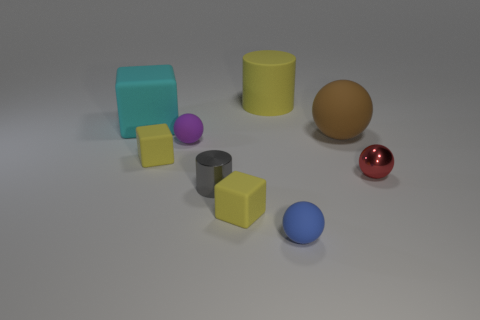Subtract all spheres. How many objects are left? 5 Subtract all yellow blocks. How many blocks are left? 1 Subtract all small purple matte balls. How many balls are left? 3 Subtract 0 brown blocks. How many objects are left? 9 Subtract 2 spheres. How many spheres are left? 2 Subtract all gray cylinders. Subtract all yellow blocks. How many cylinders are left? 1 Subtract all green cylinders. How many red balls are left? 1 Subtract all large blocks. Subtract all large rubber things. How many objects are left? 5 Add 9 small red metal spheres. How many small red metal spheres are left? 10 Add 9 gray objects. How many gray objects exist? 10 